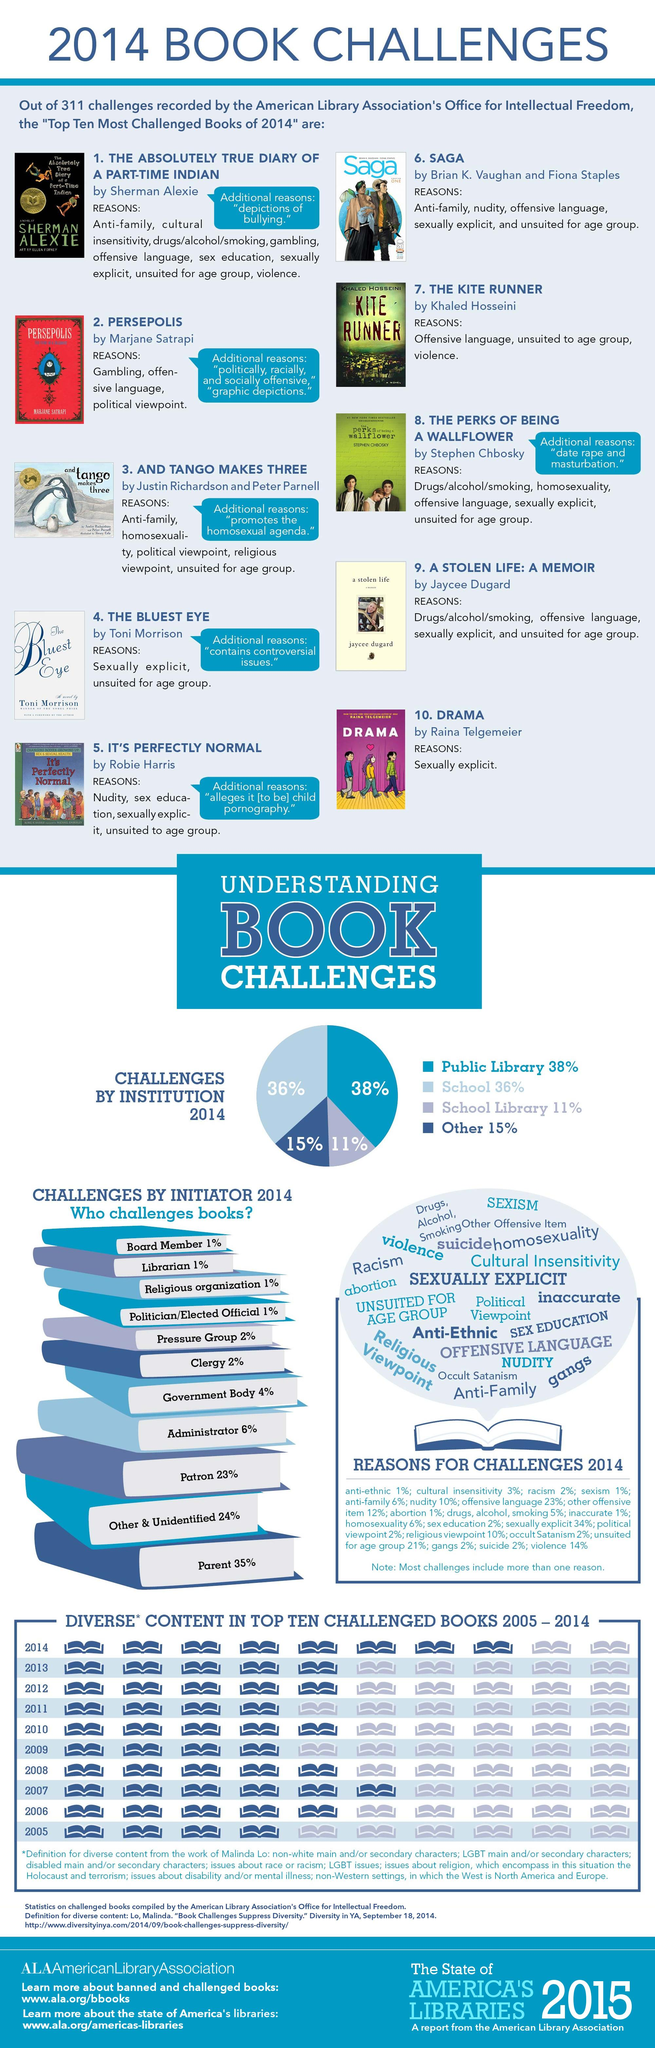Specify some key components in this picture. Of the challenges by public libraries and schools combined, 74% were successful. Thirty-six percent of challenges were brought by both parent and religious organizations, highlighting the importance of understanding and addressing the unique perspectives and concerns of both groups. Approximately 26% of challenges were initiated by school libraries and others combined. In the 2013 challenged book, there are a total of 5 diverse contents. The combined percentage of challenges brought forth by both Board members and librarians is 2%. 